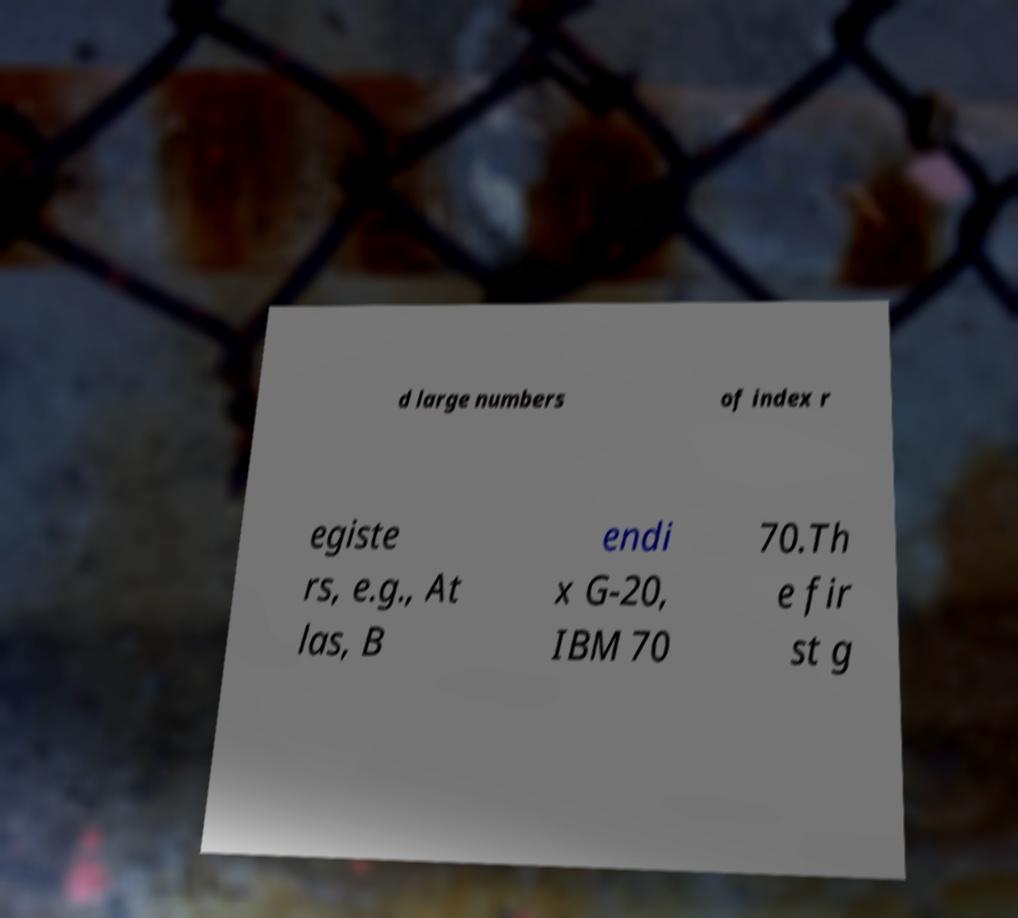Can you accurately transcribe the text from the provided image for me? d large numbers of index r egiste rs, e.g., At las, B endi x G-20, IBM 70 70.Th e fir st g 